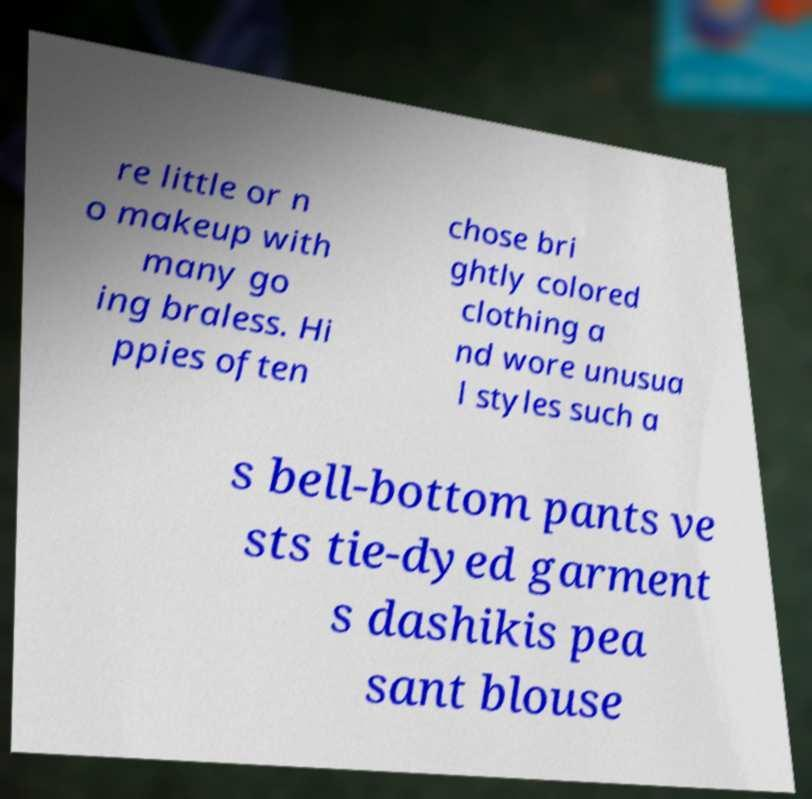What messages or text are displayed in this image? I need them in a readable, typed format. re little or n o makeup with many go ing braless. Hi ppies often chose bri ghtly colored clothing a nd wore unusua l styles such a s bell-bottom pants ve sts tie-dyed garment s dashikis pea sant blouse 